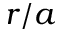Convert formula to latex. <formula><loc_0><loc_0><loc_500><loc_500>r / a</formula> 